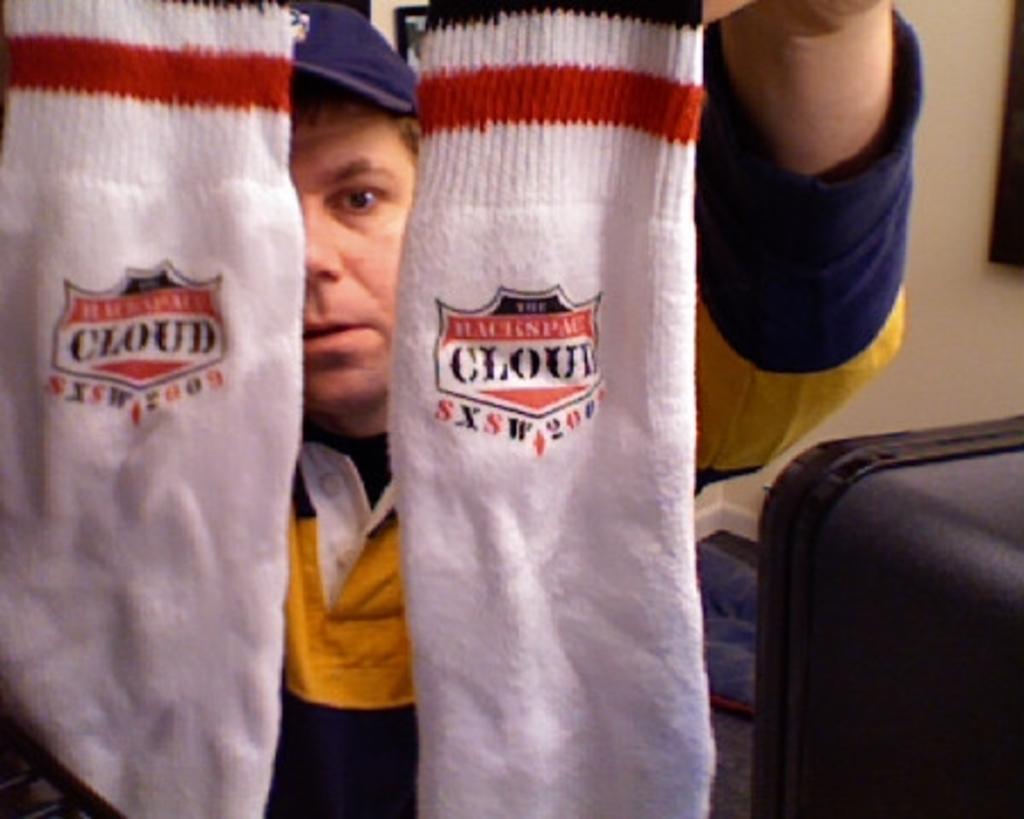Please provide a concise description of this image. In the image,there is a man he is holding two socks with his hand and there is a luggage beside the man and he is wearing blue and yellow shirt and blue cup,in the background there is a wall. 